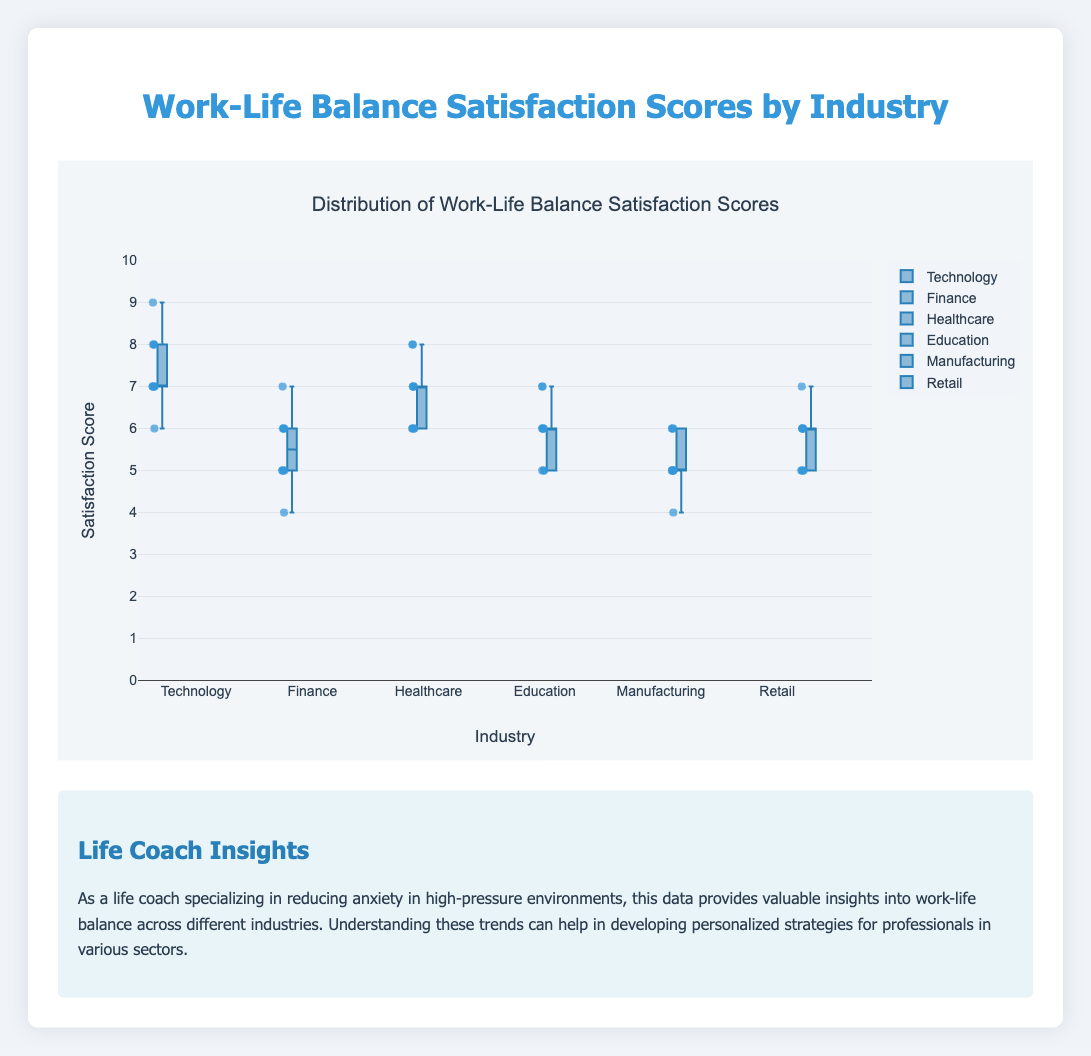What is the title of the figure? The figure's title is usually displayed at the top in a larger font and clearly labeled.
Answer: Distribution of Work-Life Balance Satisfaction Scores by Industry What is the range of satisfaction scores on the y-axis? The y-axis range is usually shown on the y-axis itself and it spans from the lowest to the highest score possible.
Answer: 0 to 10 Which industry has the highest median satisfaction score? The median satisfaction score is represented by the line inside each box in a box plot. By comparing these lines across industries, we can see which one is the highest.
Answer: Technology What is the interquartile range (IQR) for the Finance industry? The interquartile range (IQR) is the difference between the third quartile (Q3) and the first quartile (Q1), which can be observed from the top and bottom edges of the box in a box plot.
Answer: 2 How does the median satisfaction score for Retail compare to that of Education? By looking at the median lines within the boxes for both Retail and Education, one can compare their positions.
Answer: Retail's median is higher than Education's Which industry displays the most variability in satisfaction scores? The variability or spread of data in a box plot can be identified by the overall height of the box plus the length of the whiskers.
Answer: Healthcare Are there any outliers in the Technology industry? Outliers are typically indicated by individual points outside the whiskers in a box plot. By looking at the Technology box plot, we can check if there are any such points.
Answer: No Which industry has the lowest minimum satisfaction score? The minimum satisfaction score is represented by the lowest point connected to the whisker in a box plot. By finding the lowest such point across all industries, we can determine the lowest minimum score.
Answer: Manufacturing What is the general color scheme used for the box plots? The colors of the box plots can usually be determined by observing the plot; often there's a primary color for the boxes and another for the points and lines.
Answer: Blue tones 